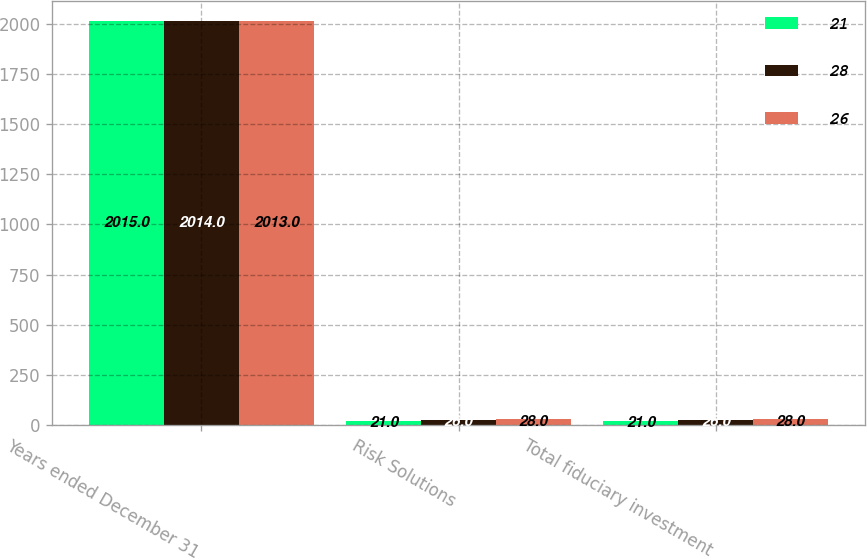Convert chart. <chart><loc_0><loc_0><loc_500><loc_500><stacked_bar_chart><ecel><fcel>Years ended December 31<fcel>Risk Solutions<fcel>Total fiduciary investment<nl><fcel>21<fcel>2015<fcel>21<fcel>21<nl><fcel>28<fcel>2014<fcel>26<fcel>26<nl><fcel>26<fcel>2013<fcel>28<fcel>28<nl></chart> 